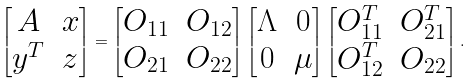Convert formula to latex. <formula><loc_0><loc_0><loc_500><loc_500>\begin{bmatrix} A & x \\ y ^ { T } & z \end{bmatrix} = \begin{bmatrix} O _ { 1 1 } & O _ { 1 2 } \\ O _ { 2 1 } & O _ { 2 2 } \end{bmatrix} \begin{bmatrix} \Lambda & 0 \\ 0 & \mu \end{bmatrix} \begin{bmatrix} O _ { 1 1 } ^ { T } & O _ { 2 1 } ^ { T } \\ O _ { 1 2 } ^ { T } & O _ { 2 2 } \end{bmatrix} .</formula> 